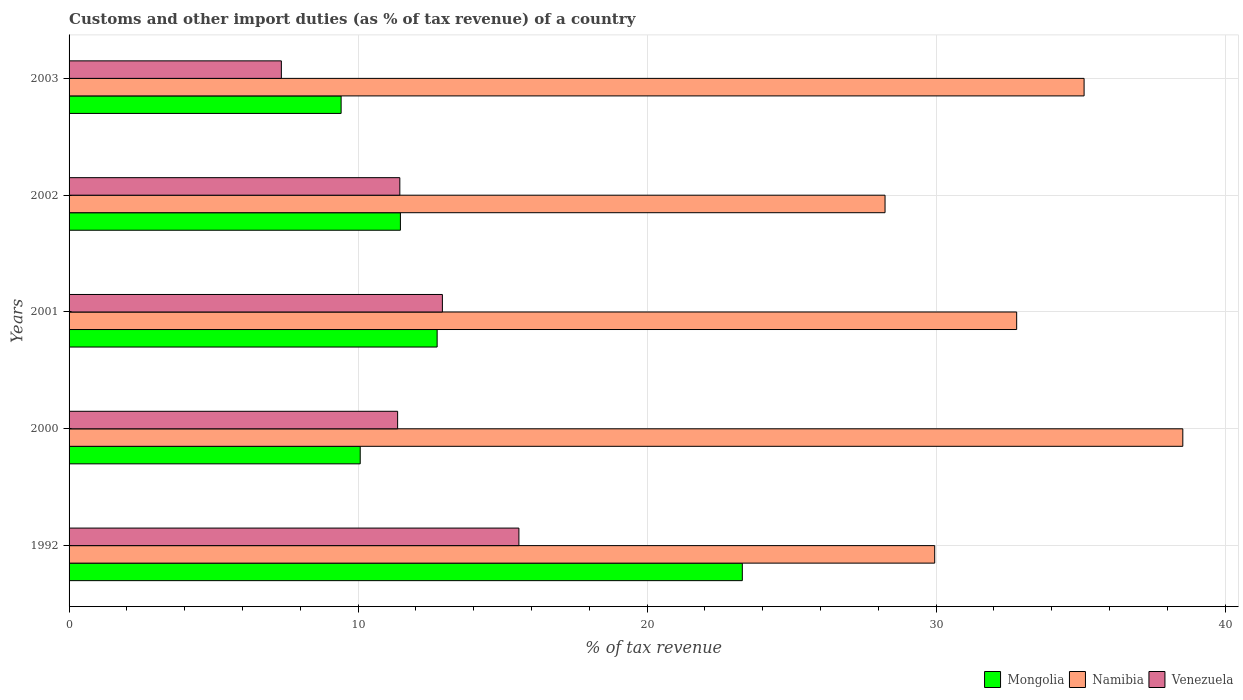How many different coloured bars are there?
Provide a succinct answer. 3. In how many cases, is the number of bars for a given year not equal to the number of legend labels?
Give a very brief answer. 0. What is the percentage of tax revenue from customs in Mongolia in 1992?
Provide a short and direct response. 23.3. Across all years, what is the maximum percentage of tax revenue from customs in Mongolia?
Your answer should be very brief. 23.3. Across all years, what is the minimum percentage of tax revenue from customs in Mongolia?
Keep it short and to the point. 9.41. In which year was the percentage of tax revenue from customs in Venezuela maximum?
Provide a succinct answer. 1992. What is the total percentage of tax revenue from customs in Venezuela in the graph?
Provide a short and direct response. 58.64. What is the difference between the percentage of tax revenue from customs in Venezuela in 1992 and that in 2001?
Make the answer very short. 2.65. What is the difference between the percentage of tax revenue from customs in Mongolia in 1992 and the percentage of tax revenue from customs in Namibia in 2001?
Make the answer very short. -9.49. What is the average percentage of tax revenue from customs in Mongolia per year?
Keep it short and to the point. 13.4. In the year 2002, what is the difference between the percentage of tax revenue from customs in Namibia and percentage of tax revenue from customs in Mongolia?
Your answer should be compact. 16.77. What is the ratio of the percentage of tax revenue from customs in Venezuela in 2000 to that in 2002?
Your answer should be very brief. 0.99. Is the percentage of tax revenue from customs in Venezuela in 1992 less than that in 2002?
Your answer should be compact. No. What is the difference between the highest and the second highest percentage of tax revenue from customs in Mongolia?
Make the answer very short. 10.56. What is the difference between the highest and the lowest percentage of tax revenue from customs in Namibia?
Provide a short and direct response. 10.3. In how many years, is the percentage of tax revenue from customs in Mongolia greater than the average percentage of tax revenue from customs in Mongolia taken over all years?
Your answer should be compact. 1. What does the 1st bar from the top in 2000 represents?
Make the answer very short. Venezuela. What does the 1st bar from the bottom in 2001 represents?
Provide a succinct answer. Mongolia. How many bars are there?
Keep it short and to the point. 15. Are all the bars in the graph horizontal?
Offer a very short reply. Yes. How many years are there in the graph?
Offer a very short reply. 5. Are the values on the major ticks of X-axis written in scientific E-notation?
Make the answer very short. No. Does the graph contain grids?
Give a very brief answer. Yes. Where does the legend appear in the graph?
Provide a short and direct response. Bottom right. How many legend labels are there?
Your answer should be very brief. 3. How are the legend labels stacked?
Make the answer very short. Horizontal. What is the title of the graph?
Your answer should be very brief. Customs and other import duties (as % of tax revenue) of a country. What is the label or title of the X-axis?
Provide a short and direct response. % of tax revenue. What is the label or title of the Y-axis?
Ensure brevity in your answer.  Years. What is the % of tax revenue of Mongolia in 1992?
Provide a succinct answer. 23.3. What is the % of tax revenue of Namibia in 1992?
Your answer should be very brief. 29.95. What is the % of tax revenue in Venezuela in 1992?
Offer a very short reply. 15.56. What is the % of tax revenue of Mongolia in 2000?
Ensure brevity in your answer.  10.07. What is the % of tax revenue in Namibia in 2000?
Provide a succinct answer. 38.54. What is the % of tax revenue of Venezuela in 2000?
Give a very brief answer. 11.37. What is the % of tax revenue in Mongolia in 2001?
Offer a very short reply. 12.74. What is the % of tax revenue in Namibia in 2001?
Give a very brief answer. 32.79. What is the % of tax revenue of Venezuela in 2001?
Give a very brief answer. 12.92. What is the % of tax revenue in Mongolia in 2002?
Offer a very short reply. 11.46. What is the % of tax revenue in Namibia in 2002?
Give a very brief answer. 28.23. What is the % of tax revenue in Venezuela in 2002?
Offer a terse response. 11.44. What is the % of tax revenue in Mongolia in 2003?
Your answer should be compact. 9.41. What is the % of tax revenue of Namibia in 2003?
Your response must be concise. 35.12. What is the % of tax revenue of Venezuela in 2003?
Ensure brevity in your answer.  7.35. Across all years, what is the maximum % of tax revenue of Mongolia?
Provide a short and direct response. 23.3. Across all years, what is the maximum % of tax revenue in Namibia?
Provide a succinct answer. 38.54. Across all years, what is the maximum % of tax revenue in Venezuela?
Offer a very short reply. 15.56. Across all years, what is the minimum % of tax revenue in Mongolia?
Keep it short and to the point. 9.41. Across all years, what is the minimum % of tax revenue in Namibia?
Ensure brevity in your answer.  28.23. Across all years, what is the minimum % of tax revenue in Venezuela?
Your answer should be very brief. 7.35. What is the total % of tax revenue in Mongolia in the graph?
Keep it short and to the point. 66.98. What is the total % of tax revenue in Namibia in the graph?
Your answer should be compact. 164.63. What is the total % of tax revenue of Venezuela in the graph?
Give a very brief answer. 58.64. What is the difference between the % of tax revenue in Mongolia in 1992 and that in 2000?
Make the answer very short. 13.22. What is the difference between the % of tax revenue in Namibia in 1992 and that in 2000?
Provide a short and direct response. -8.58. What is the difference between the % of tax revenue in Venezuela in 1992 and that in 2000?
Provide a succinct answer. 4.2. What is the difference between the % of tax revenue in Mongolia in 1992 and that in 2001?
Ensure brevity in your answer.  10.56. What is the difference between the % of tax revenue of Namibia in 1992 and that in 2001?
Make the answer very short. -2.84. What is the difference between the % of tax revenue in Venezuela in 1992 and that in 2001?
Make the answer very short. 2.65. What is the difference between the % of tax revenue of Mongolia in 1992 and that in 2002?
Offer a very short reply. 11.83. What is the difference between the % of tax revenue of Namibia in 1992 and that in 2002?
Ensure brevity in your answer.  1.72. What is the difference between the % of tax revenue of Venezuela in 1992 and that in 2002?
Your response must be concise. 4.12. What is the difference between the % of tax revenue of Mongolia in 1992 and that in 2003?
Provide a short and direct response. 13.88. What is the difference between the % of tax revenue of Namibia in 1992 and that in 2003?
Your answer should be compact. -5.17. What is the difference between the % of tax revenue of Venezuela in 1992 and that in 2003?
Keep it short and to the point. 8.22. What is the difference between the % of tax revenue of Mongolia in 2000 and that in 2001?
Give a very brief answer. -2.66. What is the difference between the % of tax revenue of Namibia in 2000 and that in 2001?
Provide a short and direct response. 5.75. What is the difference between the % of tax revenue in Venezuela in 2000 and that in 2001?
Offer a terse response. -1.55. What is the difference between the % of tax revenue in Mongolia in 2000 and that in 2002?
Ensure brevity in your answer.  -1.39. What is the difference between the % of tax revenue in Namibia in 2000 and that in 2002?
Your answer should be compact. 10.3. What is the difference between the % of tax revenue of Venezuela in 2000 and that in 2002?
Provide a succinct answer. -0.08. What is the difference between the % of tax revenue in Mongolia in 2000 and that in 2003?
Your answer should be compact. 0.66. What is the difference between the % of tax revenue of Namibia in 2000 and that in 2003?
Offer a very short reply. 3.42. What is the difference between the % of tax revenue in Venezuela in 2000 and that in 2003?
Ensure brevity in your answer.  4.02. What is the difference between the % of tax revenue in Mongolia in 2001 and that in 2002?
Offer a very short reply. 1.27. What is the difference between the % of tax revenue of Namibia in 2001 and that in 2002?
Your answer should be compact. 4.55. What is the difference between the % of tax revenue in Venezuela in 2001 and that in 2002?
Make the answer very short. 1.47. What is the difference between the % of tax revenue in Mongolia in 2001 and that in 2003?
Offer a terse response. 3.32. What is the difference between the % of tax revenue in Namibia in 2001 and that in 2003?
Ensure brevity in your answer.  -2.33. What is the difference between the % of tax revenue in Venezuela in 2001 and that in 2003?
Offer a very short reply. 5.57. What is the difference between the % of tax revenue of Mongolia in 2002 and that in 2003?
Your answer should be compact. 2.05. What is the difference between the % of tax revenue of Namibia in 2002 and that in 2003?
Provide a short and direct response. -6.89. What is the difference between the % of tax revenue of Venezuela in 2002 and that in 2003?
Provide a short and direct response. 4.1. What is the difference between the % of tax revenue of Mongolia in 1992 and the % of tax revenue of Namibia in 2000?
Provide a succinct answer. -15.24. What is the difference between the % of tax revenue in Mongolia in 1992 and the % of tax revenue in Venezuela in 2000?
Provide a short and direct response. 11.93. What is the difference between the % of tax revenue of Namibia in 1992 and the % of tax revenue of Venezuela in 2000?
Make the answer very short. 18.58. What is the difference between the % of tax revenue in Mongolia in 1992 and the % of tax revenue in Namibia in 2001?
Your response must be concise. -9.49. What is the difference between the % of tax revenue of Mongolia in 1992 and the % of tax revenue of Venezuela in 2001?
Your response must be concise. 10.38. What is the difference between the % of tax revenue of Namibia in 1992 and the % of tax revenue of Venezuela in 2001?
Give a very brief answer. 17.03. What is the difference between the % of tax revenue in Mongolia in 1992 and the % of tax revenue in Namibia in 2002?
Offer a terse response. -4.94. What is the difference between the % of tax revenue in Mongolia in 1992 and the % of tax revenue in Venezuela in 2002?
Your answer should be compact. 11.85. What is the difference between the % of tax revenue of Namibia in 1992 and the % of tax revenue of Venezuela in 2002?
Provide a succinct answer. 18.51. What is the difference between the % of tax revenue of Mongolia in 1992 and the % of tax revenue of Namibia in 2003?
Keep it short and to the point. -11.83. What is the difference between the % of tax revenue in Mongolia in 1992 and the % of tax revenue in Venezuela in 2003?
Your answer should be very brief. 15.95. What is the difference between the % of tax revenue of Namibia in 1992 and the % of tax revenue of Venezuela in 2003?
Provide a short and direct response. 22.61. What is the difference between the % of tax revenue of Mongolia in 2000 and the % of tax revenue of Namibia in 2001?
Give a very brief answer. -22.71. What is the difference between the % of tax revenue in Mongolia in 2000 and the % of tax revenue in Venezuela in 2001?
Provide a succinct answer. -2.84. What is the difference between the % of tax revenue of Namibia in 2000 and the % of tax revenue of Venezuela in 2001?
Your response must be concise. 25.62. What is the difference between the % of tax revenue of Mongolia in 2000 and the % of tax revenue of Namibia in 2002?
Your answer should be very brief. -18.16. What is the difference between the % of tax revenue of Mongolia in 2000 and the % of tax revenue of Venezuela in 2002?
Make the answer very short. -1.37. What is the difference between the % of tax revenue of Namibia in 2000 and the % of tax revenue of Venezuela in 2002?
Offer a terse response. 27.09. What is the difference between the % of tax revenue of Mongolia in 2000 and the % of tax revenue of Namibia in 2003?
Keep it short and to the point. -25.05. What is the difference between the % of tax revenue in Mongolia in 2000 and the % of tax revenue in Venezuela in 2003?
Your answer should be compact. 2.73. What is the difference between the % of tax revenue in Namibia in 2000 and the % of tax revenue in Venezuela in 2003?
Provide a short and direct response. 31.19. What is the difference between the % of tax revenue in Mongolia in 2001 and the % of tax revenue in Namibia in 2002?
Provide a succinct answer. -15.5. What is the difference between the % of tax revenue in Mongolia in 2001 and the % of tax revenue in Venezuela in 2002?
Make the answer very short. 1.29. What is the difference between the % of tax revenue of Namibia in 2001 and the % of tax revenue of Venezuela in 2002?
Give a very brief answer. 21.34. What is the difference between the % of tax revenue of Mongolia in 2001 and the % of tax revenue of Namibia in 2003?
Make the answer very short. -22.39. What is the difference between the % of tax revenue in Mongolia in 2001 and the % of tax revenue in Venezuela in 2003?
Keep it short and to the point. 5.39. What is the difference between the % of tax revenue of Namibia in 2001 and the % of tax revenue of Venezuela in 2003?
Provide a succinct answer. 25.44. What is the difference between the % of tax revenue in Mongolia in 2002 and the % of tax revenue in Namibia in 2003?
Your answer should be compact. -23.66. What is the difference between the % of tax revenue of Mongolia in 2002 and the % of tax revenue of Venezuela in 2003?
Ensure brevity in your answer.  4.12. What is the difference between the % of tax revenue in Namibia in 2002 and the % of tax revenue in Venezuela in 2003?
Your answer should be very brief. 20.89. What is the average % of tax revenue of Mongolia per year?
Give a very brief answer. 13.4. What is the average % of tax revenue in Namibia per year?
Keep it short and to the point. 32.93. What is the average % of tax revenue of Venezuela per year?
Make the answer very short. 11.73. In the year 1992, what is the difference between the % of tax revenue of Mongolia and % of tax revenue of Namibia?
Give a very brief answer. -6.66. In the year 1992, what is the difference between the % of tax revenue in Mongolia and % of tax revenue in Venezuela?
Offer a terse response. 7.73. In the year 1992, what is the difference between the % of tax revenue of Namibia and % of tax revenue of Venezuela?
Make the answer very short. 14.39. In the year 2000, what is the difference between the % of tax revenue in Mongolia and % of tax revenue in Namibia?
Offer a terse response. -28.46. In the year 2000, what is the difference between the % of tax revenue of Mongolia and % of tax revenue of Venezuela?
Provide a succinct answer. -1.29. In the year 2000, what is the difference between the % of tax revenue of Namibia and % of tax revenue of Venezuela?
Your answer should be very brief. 27.17. In the year 2001, what is the difference between the % of tax revenue of Mongolia and % of tax revenue of Namibia?
Give a very brief answer. -20.05. In the year 2001, what is the difference between the % of tax revenue of Mongolia and % of tax revenue of Venezuela?
Your answer should be very brief. -0.18. In the year 2001, what is the difference between the % of tax revenue in Namibia and % of tax revenue in Venezuela?
Offer a very short reply. 19.87. In the year 2002, what is the difference between the % of tax revenue in Mongolia and % of tax revenue in Namibia?
Give a very brief answer. -16.77. In the year 2002, what is the difference between the % of tax revenue of Mongolia and % of tax revenue of Venezuela?
Give a very brief answer. 0.02. In the year 2002, what is the difference between the % of tax revenue of Namibia and % of tax revenue of Venezuela?
Provide a succinct answer. 16.79. In the year 2003, what is the difference between the % of tax revenue of Mongolia and % of tax revenue of Namibia?
Offer a terse response. -25.71. In the year 2003, what is the difference between the % of tax revenue in Mongolia and % of tax revenue in Venezuela?
Your answer should be very brief. 2.07. In the year 2003, what is the difference between the % of tax revenue of Namibia and % of tax revenue of Venezuela?
Provide a succinct answer. 27.78. What is the ratio of the % of tax revenue of Mongolia in 1992 to that in 2000?
Keep it short and to the point. 2.31. What is the ratio of the % of tax revenue in Namibia in 1992 to that in 2000?
Your response must be concise. 0.78. What is the ratio of the % of tax revenue in Venezuela in 1992 to that in 2000?
Offer a very short reply. 1.37. What is the ratio of the % of tax revenue in Mongolia in 1992 to that in 2001?
Your response must be concise. 1.83. What is the ratio of the % of tax revenue of Namibia in 1992 to that in 2001?
Your answer should be very brief. 0.91. What is the ratio of the % of tax revenue in Venezuela in 1992 to that in 2001?
Your answer should be compact. 1.2. What is the ratio of the % of tax revenue of Mongolia in 1992 to that in 2002?
Your answer should be very brief. 2.03. What is the ratio of the % of tax revenue in Namibia in 1992 to that in 2002?
Your answer should be compact. 1.06. What is the ratio of the % of tax revenue of Venezuela in 1992 to that in 2002?
Provide a short and direct response. 1.36. What is the ratio of the % of tax revenue in Mongolia in 1992 to that in 2003?
Offer a terse response. 2.47. What is the ratio of the % of tax revenue in Namibia in 1992 to that in 2003?
Your response must be concise. 0.85. What is the ratio of the % of tax revenue of Venezuela in 1992 to that in 2003?
Offer a terse response. 2.12. What is the ratio of the % of tax revenue of Mongolia in 2000 to that in 2001?
Offer a very short reply. 0.79. What is the ratio of the % of tax revenue in Namibia in 2000 to that in 2001?
Your answer should be very brief. 1.18. What is the ratio of the % of tax revenue of Venezuela in 2000 to that in 2001?
Provide a succinct answer. 0.88. What is the ratio of the % of tax revenue in Mongolia in 2000 to that in 2002?
Offer a terse response. 0.88. What is the ratio of the % of tax revenue in Namibia in 2000 to that in 2002?
Give a very brief answer. 1.36. What is the ratio of the % of tax revenue in Mongolia in 2000 to that in 2003?
Make the answer very short. 1.07. What is the ratio of the % of tax revenue of Namibia in 2000 to that in 2003?
Make the answer very short. 1.1. What is the ratio of the % of tax revenue of Venezuela in 2000 to that in 2003?
Offer a very short reply. 1.55. What is the ratio of the % of tax revenue of Mongolia in 2001 to that in 2002?
Your answer should be compact. 1.11. What is the ratio of the % of tax revenue in Namibia in 2001 to that in 2002?
Your response must be concise. 1.16. What is the ratio of the % of tax revenue in Venezuela in 2001 to that in 2002?
Your answer should be very brief. 1.13. What is the ratio of the % of tax revenue of Mongolia in 2001 to that in 2003?
Provide a short and direct response. 1.35. What is the ratio of the % of tax revenue in Namibia in 2001 to that in 2003?
Ensure brevity in your answer.  0.93. What is the ratio of the % of tax revenue in Venezuela in 2001 to that in 2003?
Provide a short and direct response. 1.76. What is the ratio of the % of tax revenue of Mongolia in 2002 to that in 2003?
Your answer should be very brief. 1.22. What is the ratio of the % of tax revenue in Namibia in 2002 to that in 2003?
Offer a very short reply. 0.8. What is the ratio of the % of tax revenue of Venezuela in 2002 to that in 2003?
Ensure brevity in your answer.  1.56. What is the difference between the highest and the second highest % of tax revenue of Mongolia?
Keep it short and to the point. 10.56. What is the difference between the highest and the second highest % of tax revenue of Namibia?
Your answer should be compact. 3.42. What is the difference between the highest and the second highest % of tax revenue in Venezuela?
Provide a succinct answer. 2.65. What is the difference between the highest and the lowest % of tax revenue of Mongolia?
Offer a very short reply. 13.88. What is the difference between the highest and the lowest % of tax revenue of Namibia?
Give a very brief answer. 10.3. What is the difference between the highest and the lowest % of tax revenue in Venezuela?
Ensure brevity in your answer.  8.22. 